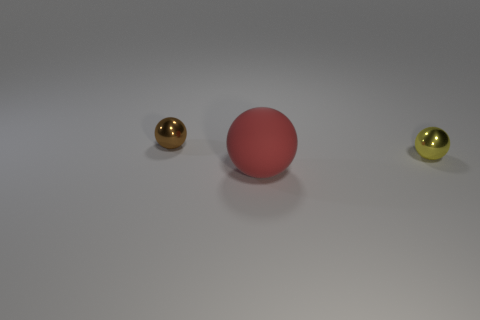Is there a cyan sphere that has the same material as the yellow thing?
Provide a succinct answer. No. Is there a small yellow ball to the left of the metallic ball on the right side of the metal thing that is to the left of the red ball?
Keep it short and to the point. No. There is a big red ball; are there any small brown metallic objects to the right of it?
Your answer should be very brief. No. Is there a tiny ball that has the same color as the large matte thing?
Offer a very short reply. No. What number of tiny things are either green spheres or brown metal things?
Offer a terse response. 1. Are the sphere that is to the left of the big rubber ball and the red thing made of the same material?
Provide a short and direct response. No. What is the shape of the small metal thing that is on the left side of the tiny metallic ball in front of the small object behind the small yellow metal object?
Offer a very short reply. Sphere. What number of blue things are shiny spheres or big rubber spheres?
Your answer should be very brief. 0. Are there an equal number of shiny balls that are right of the red rubber object and small yellow things that are behind the yellow ball?
Give a very brief answer. No. Does the yellow thing that is on the right side of the big rubber thing have the same shape as the tiny shiny object left of the yellow ball?
Give a very brief answer. Yes. 